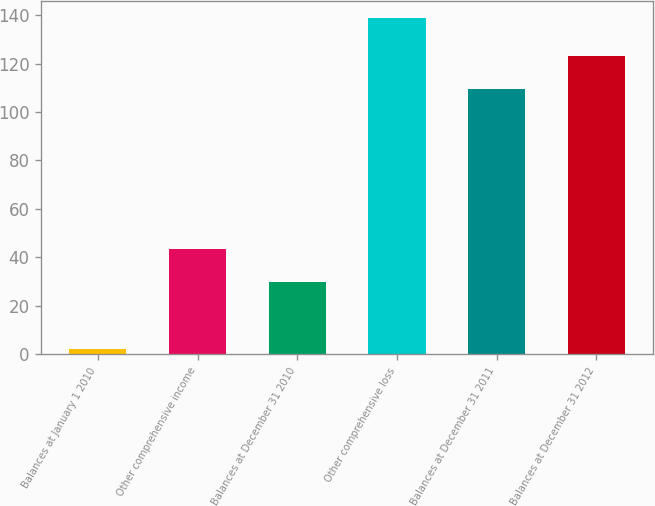<chart> <loc_0><loc_0><loc_500><loc_500><bar_chart><fcel>Balances at January 1 2010<fcel>Other comprehensive income<fcel>Balances at December 31 2010<fcel>Other comprehensive loss<fcel>Balances at December 31 2011<fcel>Balances at December 31 2012<nl><fcel>2<fcel>43.4<fcel>29.7<fcel>139<fcel>109.3<fcel>123<nl></chart> 